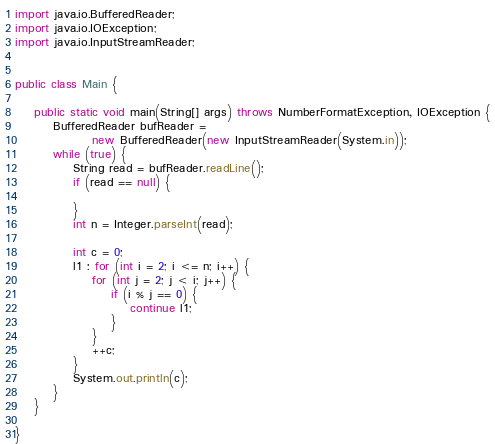Convert code to text. <code><loc_0><loc_0><loc_500><loc_500><_Java_>import java.io.BufferedReader;
import java.io.IOException;
import java.io.InputStreamReader;


public class Main {

	public static void main(String[] args) throws NumberFormatException, IOException {
		BufferedReader bufReader =
				new BufferedReader(new InputStreamReader(System.in));
		while (true) {
			String read = bufReader.readLine();
			if (read == null) {

			}
			int n = Integer.parseInt(read);

			int c = 0;
			l1 : for (int i = 2; i <= n; i++) {
				for (int j = 2; j < i; j++) {
					if (i % j == 0) {
						continue l1;
					}
				}
				++c;
			}
			System.out.println(c);
		}
	}

}</code> 